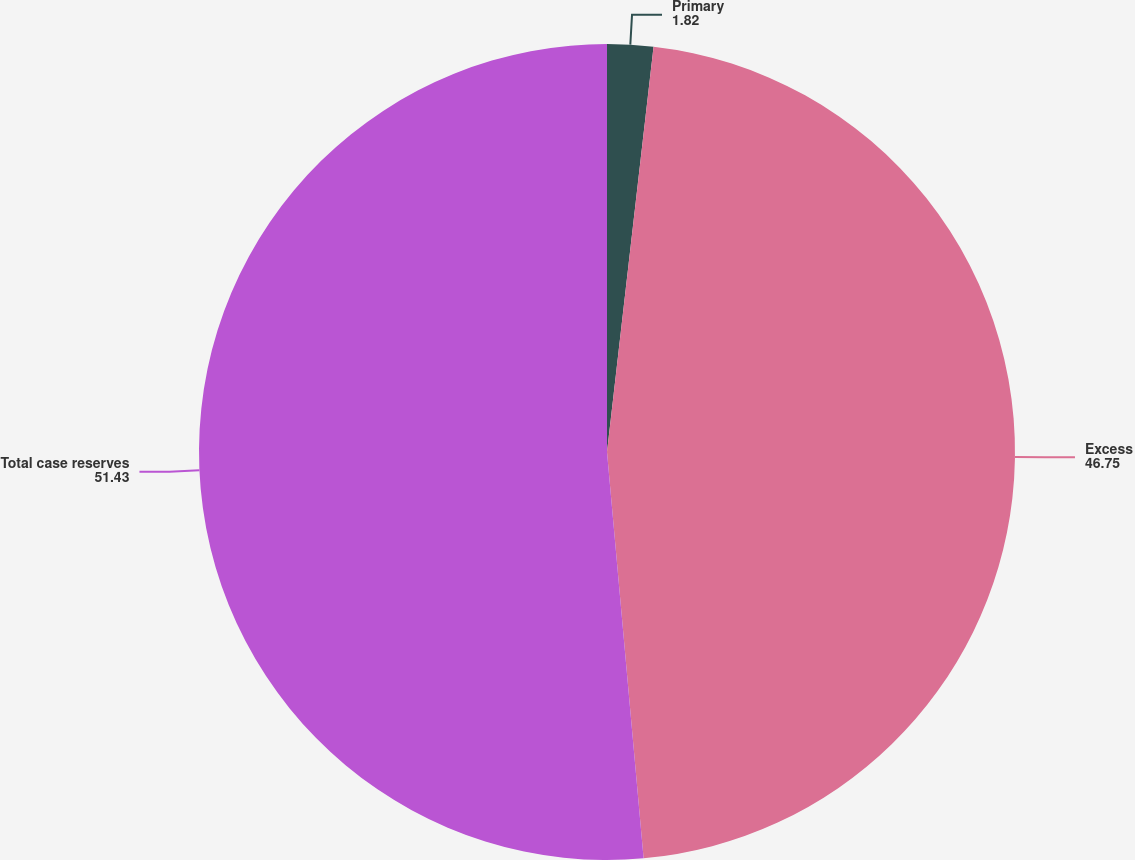Convert chart. <chart><loc_0><loc_0><loc_500><loc_500><pie_chart><fcel>Primary<fcel>Excess<fcel>Total case reserves<nl><fcel>1.82%<fcel>46.75%<fcel>51.43%<nl></chart> 